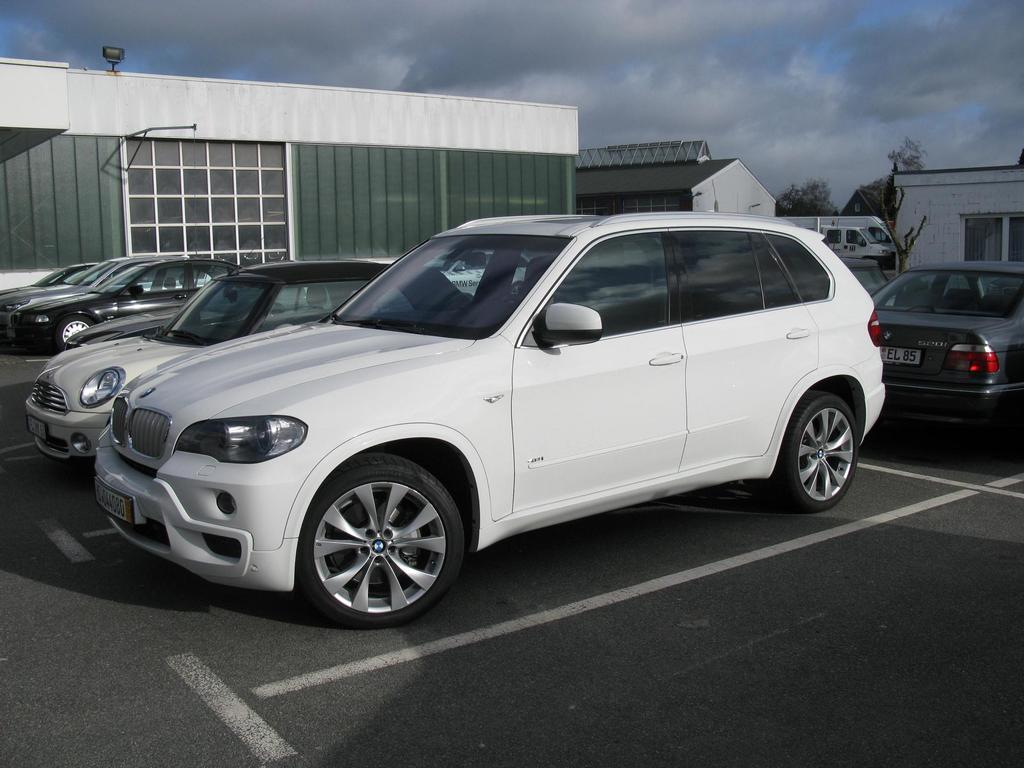What can be seen on the ground in the image? There are many cars parked on the ground in the image. What type of structures are visible in the background of the image? There are houses visible in the background of the image. What is visible in the sky in the image? The sky is visible in the background of the image. What type of sheet is covering the cars in the image? There is no sheet covering the cars in the image; they are parked on the ground without any coverings. 